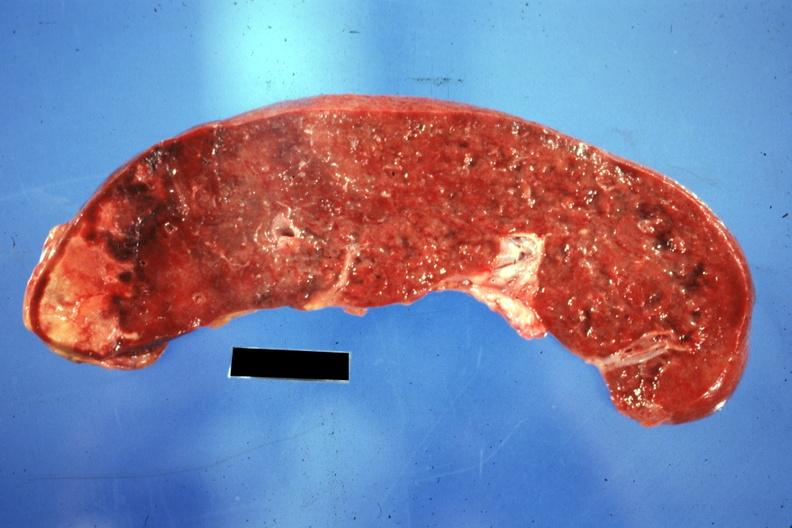does intraductal papillomatosis show cut surface of spleen with one large infarct classical embolus from nonbacterial endocarditis on mitral valve?
Answer the question using a single word or phrase. No 